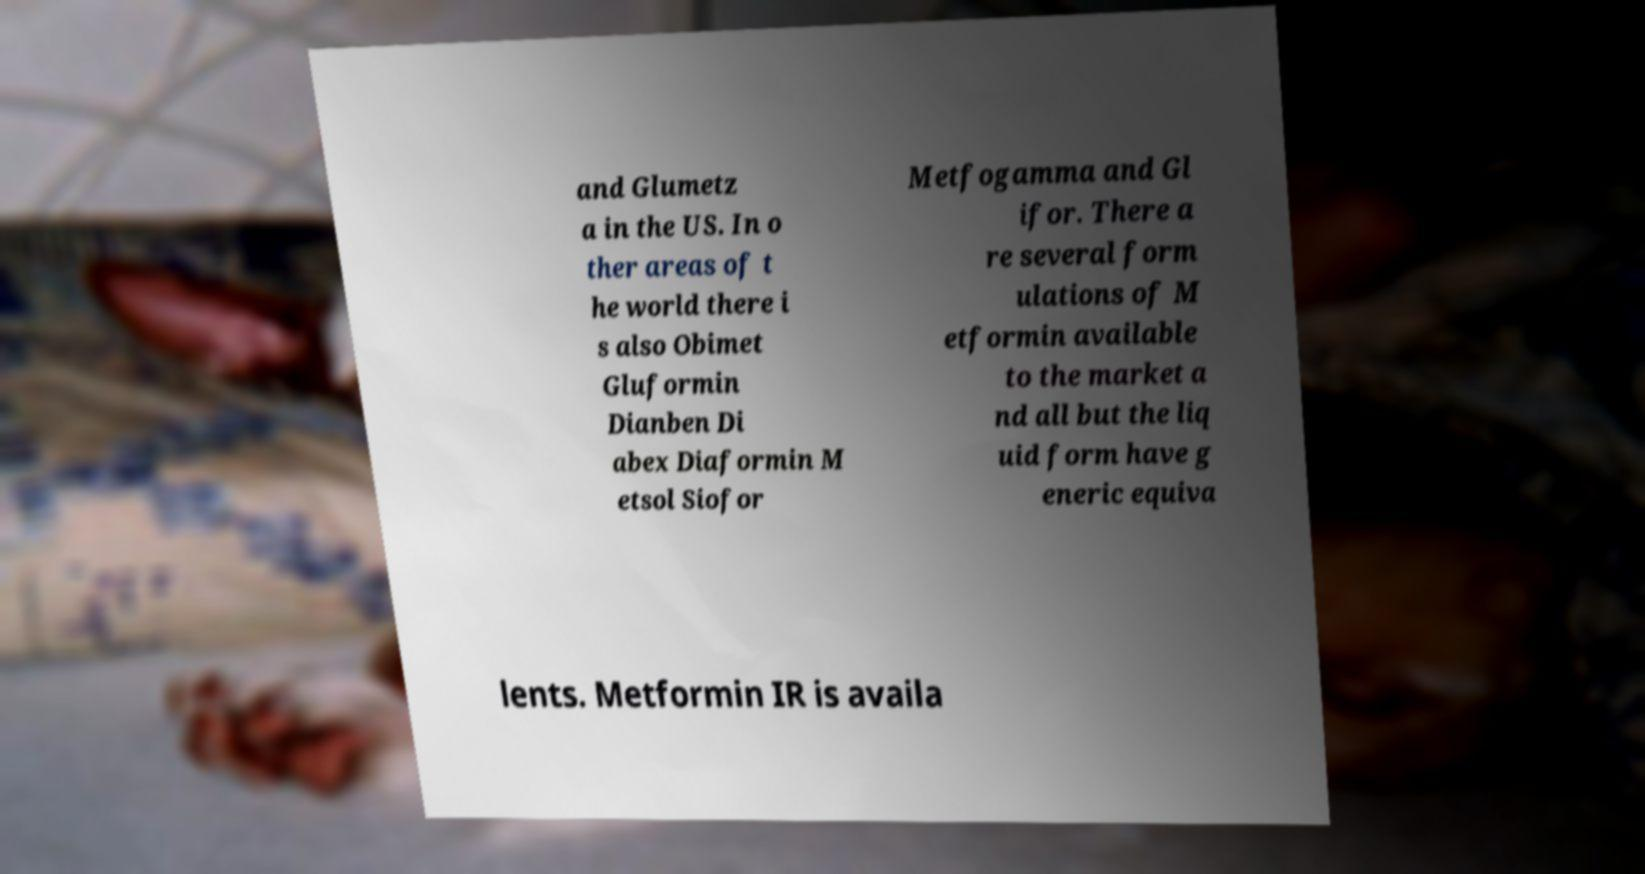What messages or text are displayed in this image? I need them in a readable, typed format. and Glumetz a in the US. In o ther areas of t he world there i s also Obimet Gluformin Dianben Di abex Diaformin M etsol Siofor Metfogamma and Gl ifor. There a re several form ulations of M etformin available to the market a nd all but the liq uid form have g eneric equiva lents. Metformin IR is availa 